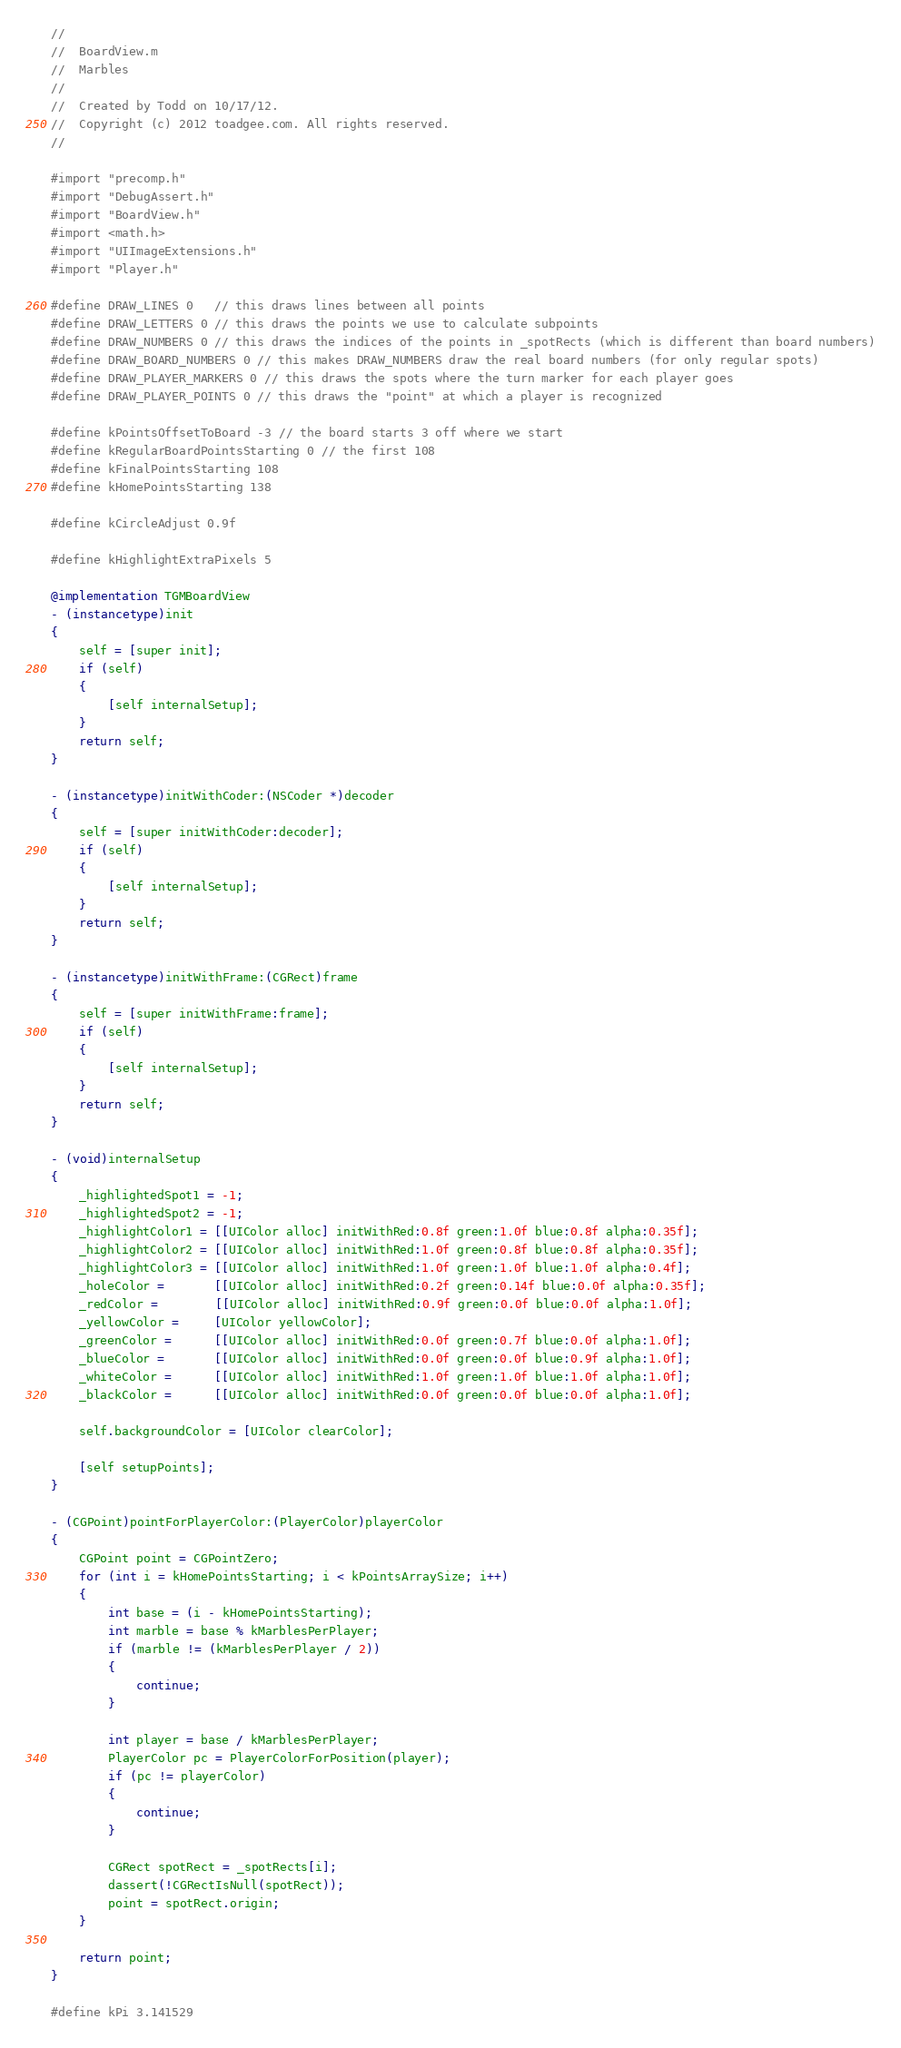<code> <loc_0><loc_0><loc_500><loc_500><_ObjectiveC_>//
//	BoardView.m
//	Marbles
//
//	Created by Todd on 10/17/12.
//	Copyright (c) 2012 toadgee.com. All rights reserved.
//

#import "precomp.h"
#import "DebugAssert.h"
#import "BoardView.h"
#import <math.h>
#import "UIImageExtensions.h"
#import "Player.h"

#define DRAW_LINES 0   // this draws lines between all points
#define DRAW_LETTERS 0 // this draws the points we use to calculate subpoints
#define DRAW_NUMBERS 0 // this draws the indices of the points in _spotRects (which is different than board numbers)
#define DRAW_BOARD_NUMBERS 0 // this makes DRAW_NUMBERS draw the real board numbers (for only regular spots)
#define DRAW_PLAYER_MARKERS 0 // this draws the spots where the turn marker for each player goes
#define DRAW_PLAYER_POINTS 0 // this draws the "point" at which a player is recognized

#define kPointsOffsetToBoard -3 // the board starts 3 off where we start
#define kRegularBoardPointsStarting 0 // the first 108
#define kFinalPointsStarting 108
#define kHomePointsStarting 138

#define kCircleAdjust 0.9f

#define kHighlightExtraPixels 5

@implementation TGMBoardView
- (instancetype)init
{
	self = [super init];
	if (self)
	{
		[self internalSetup];
	}
	return self;
}

- (instancetype)initWithCoder:(NSCoder *)decoder
{
	self = [super initWithCoder:decoder];
	if (self)
	{
		[self internalSetup];
	}
	return self;
}

- (instancetype)initWithFrame:(CGRect)frame
{
	self = [super initWithFrame:frame];
	if (self)
	{
		[self internalSetup];
	}
	return self;
}

- (void)internalSetup
{
	_highlightedSpot1 = -1;
	_highlightedSpot2 = -1;
	_highlightColor1 = [[UIColor alloc] initWithRed:0.8f green:1.0f blue:0.8f alpha:0.35f];
	_highlightColor2 = [[UIColor alloc] initWithRed:1.0f green:0.8f blue:0.8f alpha:0.35f];
	_highlightColor3 = [[UIColor alloc] initWithRed:1.0f green:1.0f blue:1.0f alpha:0.4f];
	_holeColor =       [[UIColor alloc] initWithRed:0.2f green:0.14f blue:0.0f alpha:0.35f];
	_redColor =        [[UIColor alloc] initWithRed:0.9f green:0.0f blue:0.0f alpha:1.0f];
	_yellowColor =     [UIColor yellowColor];
	_greenColor =      [[UIColor alloc] initWithRed:0.0f green:0.7f blue:0.0f alpha:1.0f];
	_blueColor =       [[UIColor alloc] initWithRed:0.0f green:0.0f blue:0.9f alpha:1.0f];
	_whiteColor =      [[UIColor alloc] initWithRed:1.0f green:1.0f blue:1.0f alpha:1.0f];
	_blackColor =      [[UIColor alloc] initWithRed:0.0f green:0.0f blue:0.0f alpha:1.0f];
	
	self.backgroundColor = [UIColor clearColor];
	
	[self setupPoints];
}

- (CGPoint)pointForPlayerColor:(PlayerColor)playerColor
{
	CGPoint point = CGPointZero;
	for (int i = kHomePointsStarting; i < kPointsArraySize; i++)
	{
		int base = (i - kHomePointsStarting);
		int marble = base % kMarblesPerPlayer;
		if (marble != (kMarblesPerPlayer / 2))
		{
			continue;
		}
		
		int player = base / kMarblesPerPlayer;
		PlayerColor pc = PlayerColorForPosition(player);
		if (pc != playerColor)
		{
			continue;
		}
		
		CGRect spotRect = _spotRects[i];
		dassert(!CGRectIsNull(spotRect));
		point = spotRect.origin;
	}
	
	return point;
}

#define kPi 3.141529</code> 